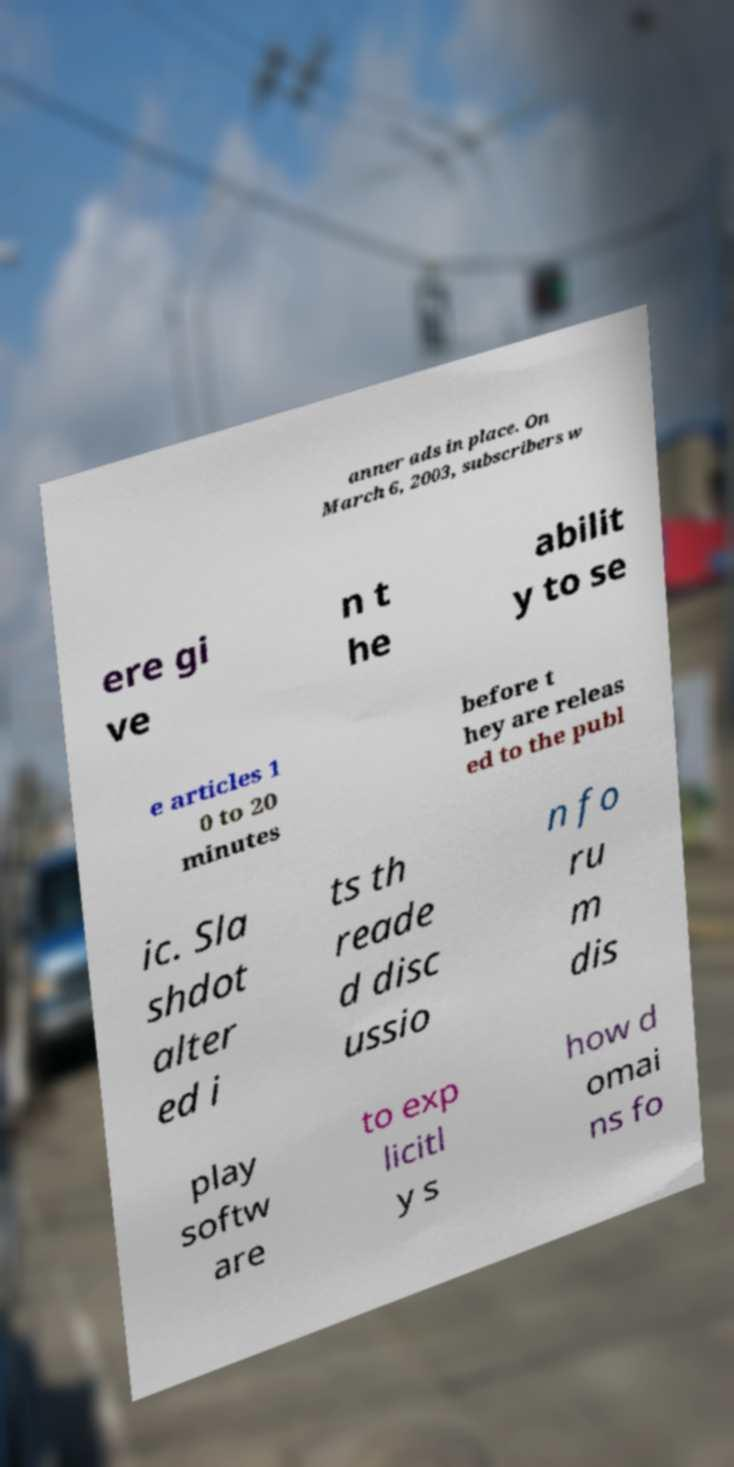What messages or text are displayed in this image? I need them in a readable, typed format. anner ads in place. On March 6, 2003, subscribers w ere gi ve n t he abilit y to se e articles 1 0 to 20 minutes before t hey are releas ed to the publ ic. Sla shdot alter ed i ts th reade d disc ussio n fo ru m dis play softw are to exp licitl y s how d omai ns fo 